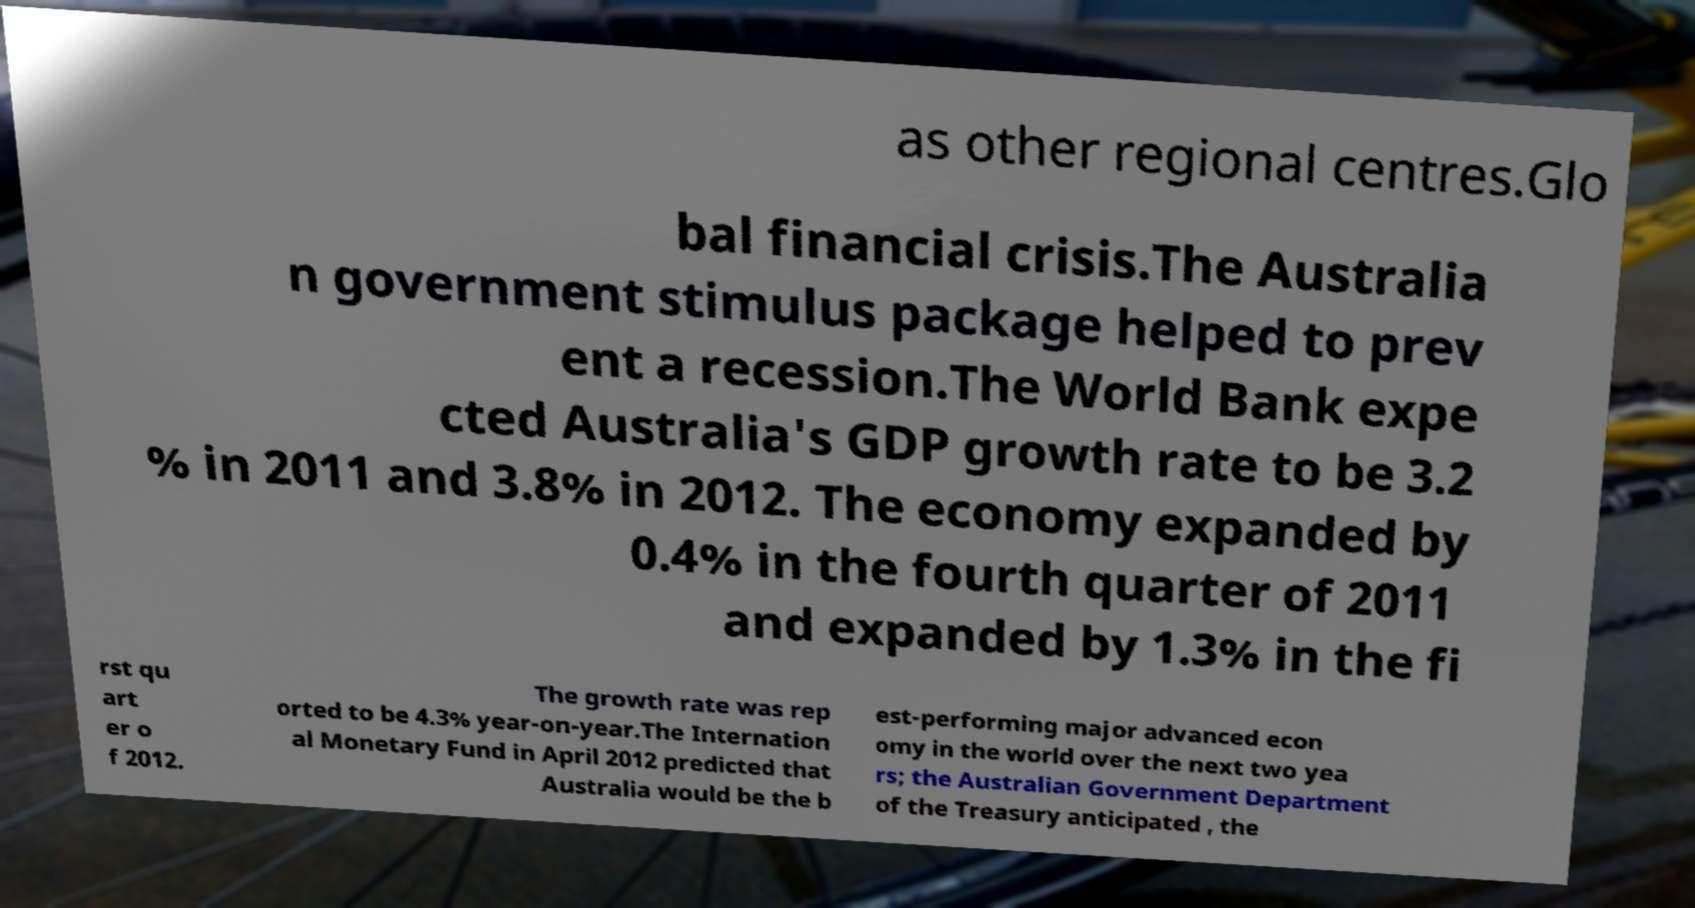Could you extract and type out the text from this image? as other regional centres.Glo bal financial crisis.The Australia n government stimulus package helped to prev ent a recession.The World Bank expe cted Australia's GDP growth rate to be 3.2 % in 2011 and 3.8% in 2012. The economy expanded by 0.4% in the fourth quarter of 2011 and expanded by 1.3% in the fi rst qu art er o f 2012. The growth rate was rep orted to be 4.3% year-on-year.The Internation al Monetary Fund in April 2012 predicted that Australia would be the b est-performing major advanced econ omy in the world over the next two yea rs; the Australian Government Department of the Treasury anticipated , the 